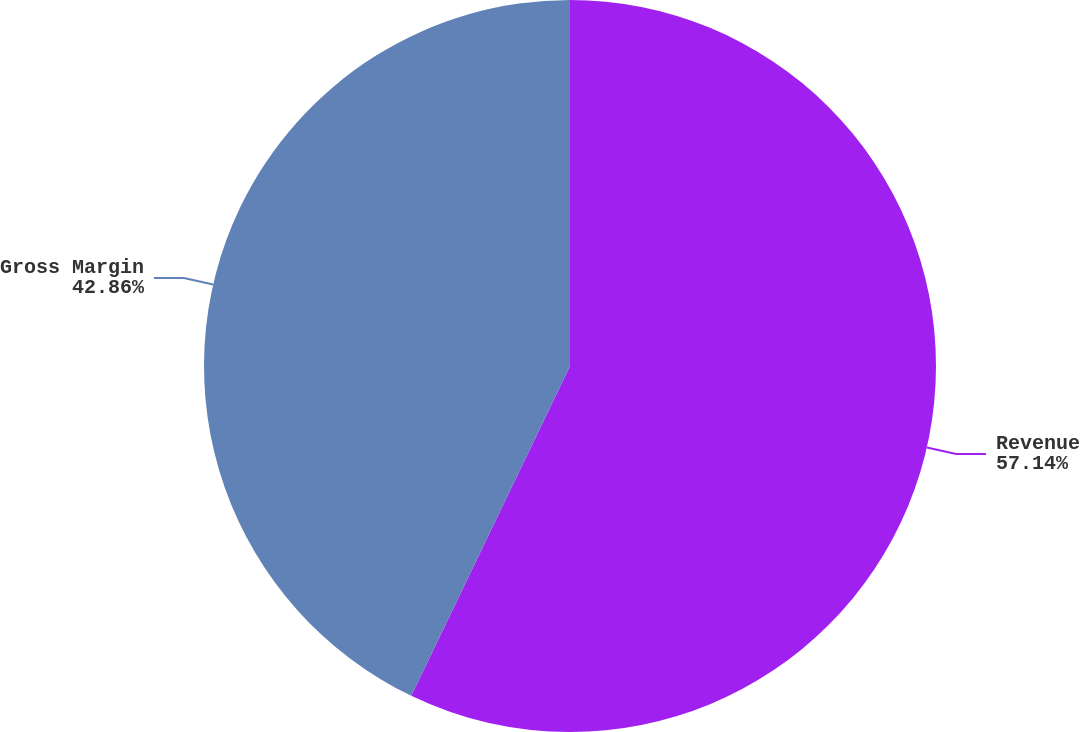<chart> <loc_0><loc_0><loc_500><loc_500><pie_chart><fcel>Revenue<fcel>Gross Margin<nl><fcel>57.14%<fcel>42.86%<nl></chart> 